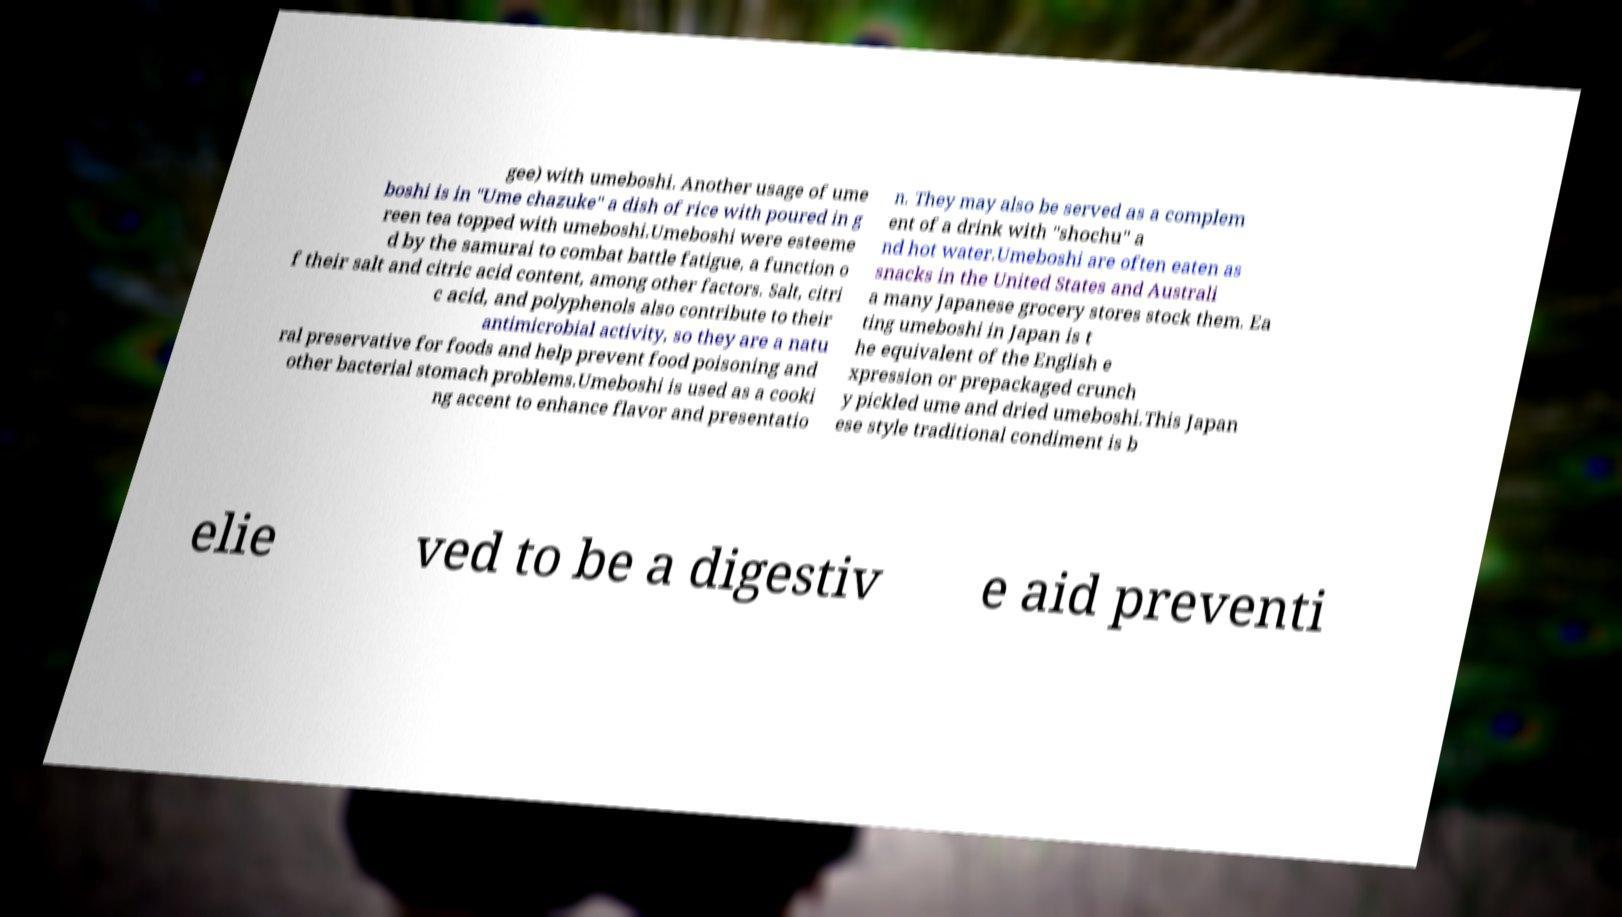Can you read and provide the text displayed in the image?This photo seems to have some interesting text. Can you extract and type it out for me? gee) with umeboshi. Another usage of ume boshi is in "Ume chazuke" a dish of rice with poured in g reen tea topped with umeboshi.Umeboshi were esteeme d by the samurai to combat battle fatigue, a function o f their salt and citric acid content, among other factors. Salt, citri c acid, and polyphenols also contribute to their antimicrobial activity, so they are a natu ral preservative for foods and help prevent food poisoning and other bacterial stomach problems.Umeboshi is used as a cooki ng accent to enhance flavor and presentatio n. They may also be served as a complem ent of a drink with "shochu" a nd hot water.Umeboshi are often eaten as snacks in the United States and Australi a many Japanese grocery stores stock them. Ea ting umeboshi in Japan is t he equivalent of the English e xpression or prepackaged crunch y pickled ume and dried umeboshi.This Japan ese style traditional condiment is b elie ved to be a digestiv e aid preventi 